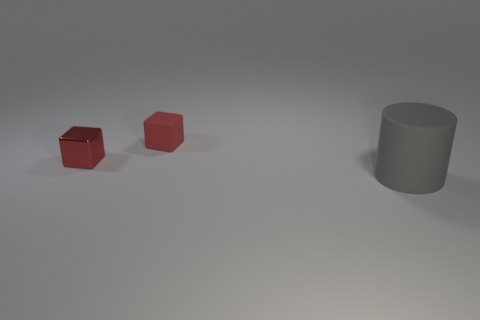Add 3 small red objects. How many objects exist? 6 Subtract 1 cylinders. How many cylinders are left? 0 Subtract 1 gray cylinders. How many objects are left? 2 Subtract all cylinders. How many objects are left? 2 Subtract all purple cylinders. Subtract all red balls. How many cylinders are left? 1 Subtract all green balls. How many brown cylinders are left? 0 Subtract all red rubber objects. Subtract all big gray matte cylinders. How many objects are left? 1 Add 3 red metallic objects. How many red metallic objects are left? 4 Add 2 tiny cubes. How many tiny cubes exist? 4 